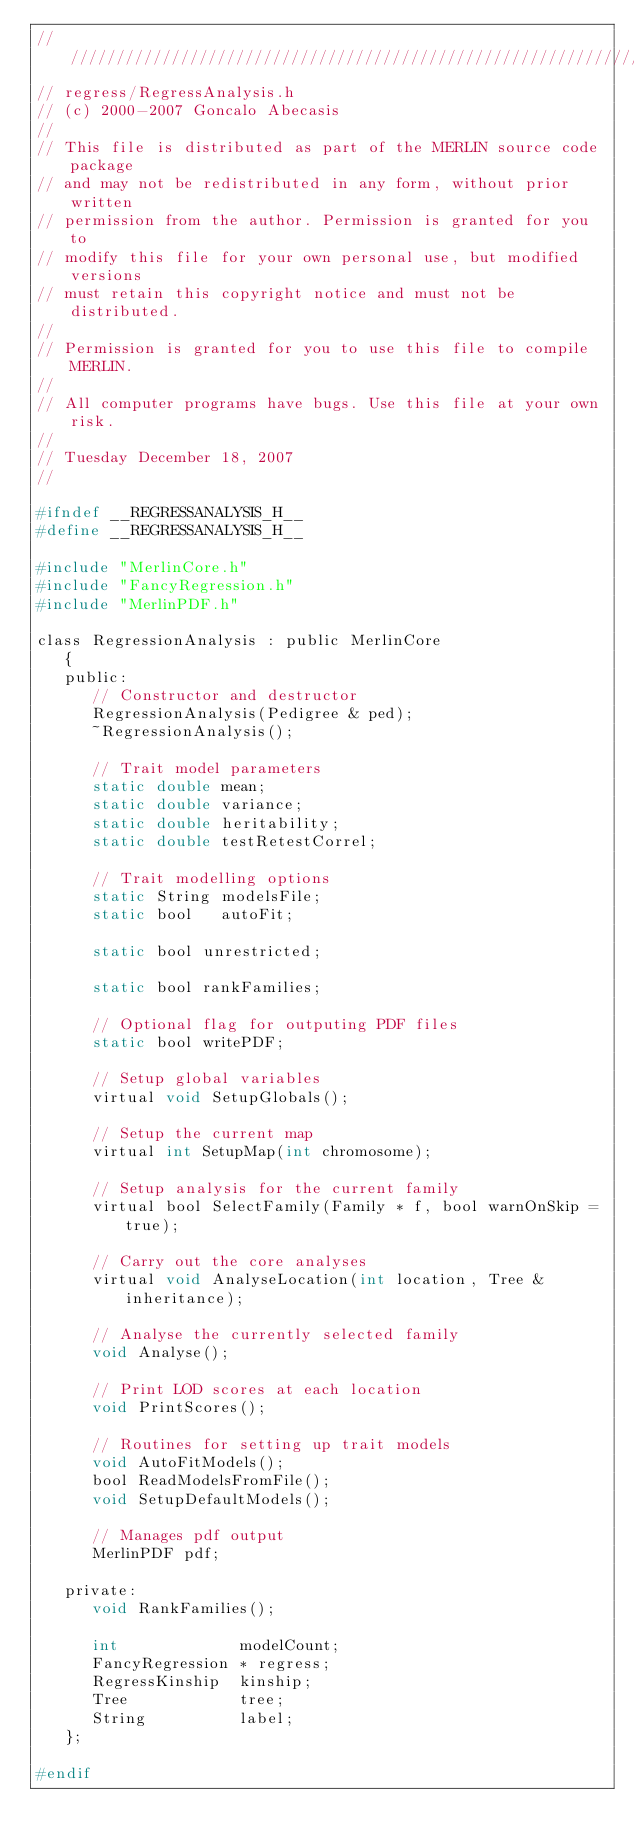Convert code to text. <code><loc_0><loc_0><loc_500><loc_500><_C_>////////////////////////////////////////////////////////////////////// 
// regress/RegressAnalysis.h 
// (c) 2000-2007 Goncalo Abecasis
// 
// This file is distributed as part of the MERLIN source code package   
// and may not be redistributed in any form, without prior written    
// permission from the author. Permission is granted for you to       
// modify this file for your own personal use, but modified versions  
// must retain this copyright notice and must not be distributed.     
// 
// Permission is granted for you to use this file to compile MERLIN.    
// 
// All computer programs have bugs. Use this file at your own risk.   
// 
// Tuesday December 18, 2007
// 
 
#ifndef __REGRESSANALYSIS_H__
#define __REGRESSANALYSIS_H__

#include "MerlinCore.h"
#include "FancyRegression.h"
#include "MerlinPDF.h"

class RegressionAnalysis : public MerlinCore
   {
   public:
      // Constructor and destructor
      RegressionAnalysis(Pedigree & ped);
      ~RegressionAnalysis();

      // Trait model parameters
      static double mean;
      static double variance;
      static double heritability;
      static double testRetestCorrel;

      // Trait modelling options
      static String modelsFile;
      static bool   autoFit;

      static bool unrestricted;

      static bool rankFamilies;

      // Optional flag for outputing PDF files
      static bool writePDF;

      // Setup global variables
      virtual void SetupGlobals();

      // Setup the current map
      virtual int SetupMap(int chromosome);

      // Setup analysis for the current family
      virtual bool SelectFamily(Family * f, bool warnOnSkip = true);

      // Carry out the core analyses
      virtual void AnalyseLocation(int location, Tree & inheritance);

      // Analyse the currently selected family
      void Analyse();

      // Print LOD scores at each location
      void PrintScores();

      // Routines for setting up trait models
      void AutoFitModels();
      bool ReadModelsFromFile();
      void SetupDefaultModels();

      // Manages pdf output
      MerlinPDF pdf;

   private:
      void RankFamilies();

      int             modelCount;
      FancyRegression * regress;
      RegressKinship  kinship;
      Tree            tree;
      String          label;
   };

#endif


 
</code> 